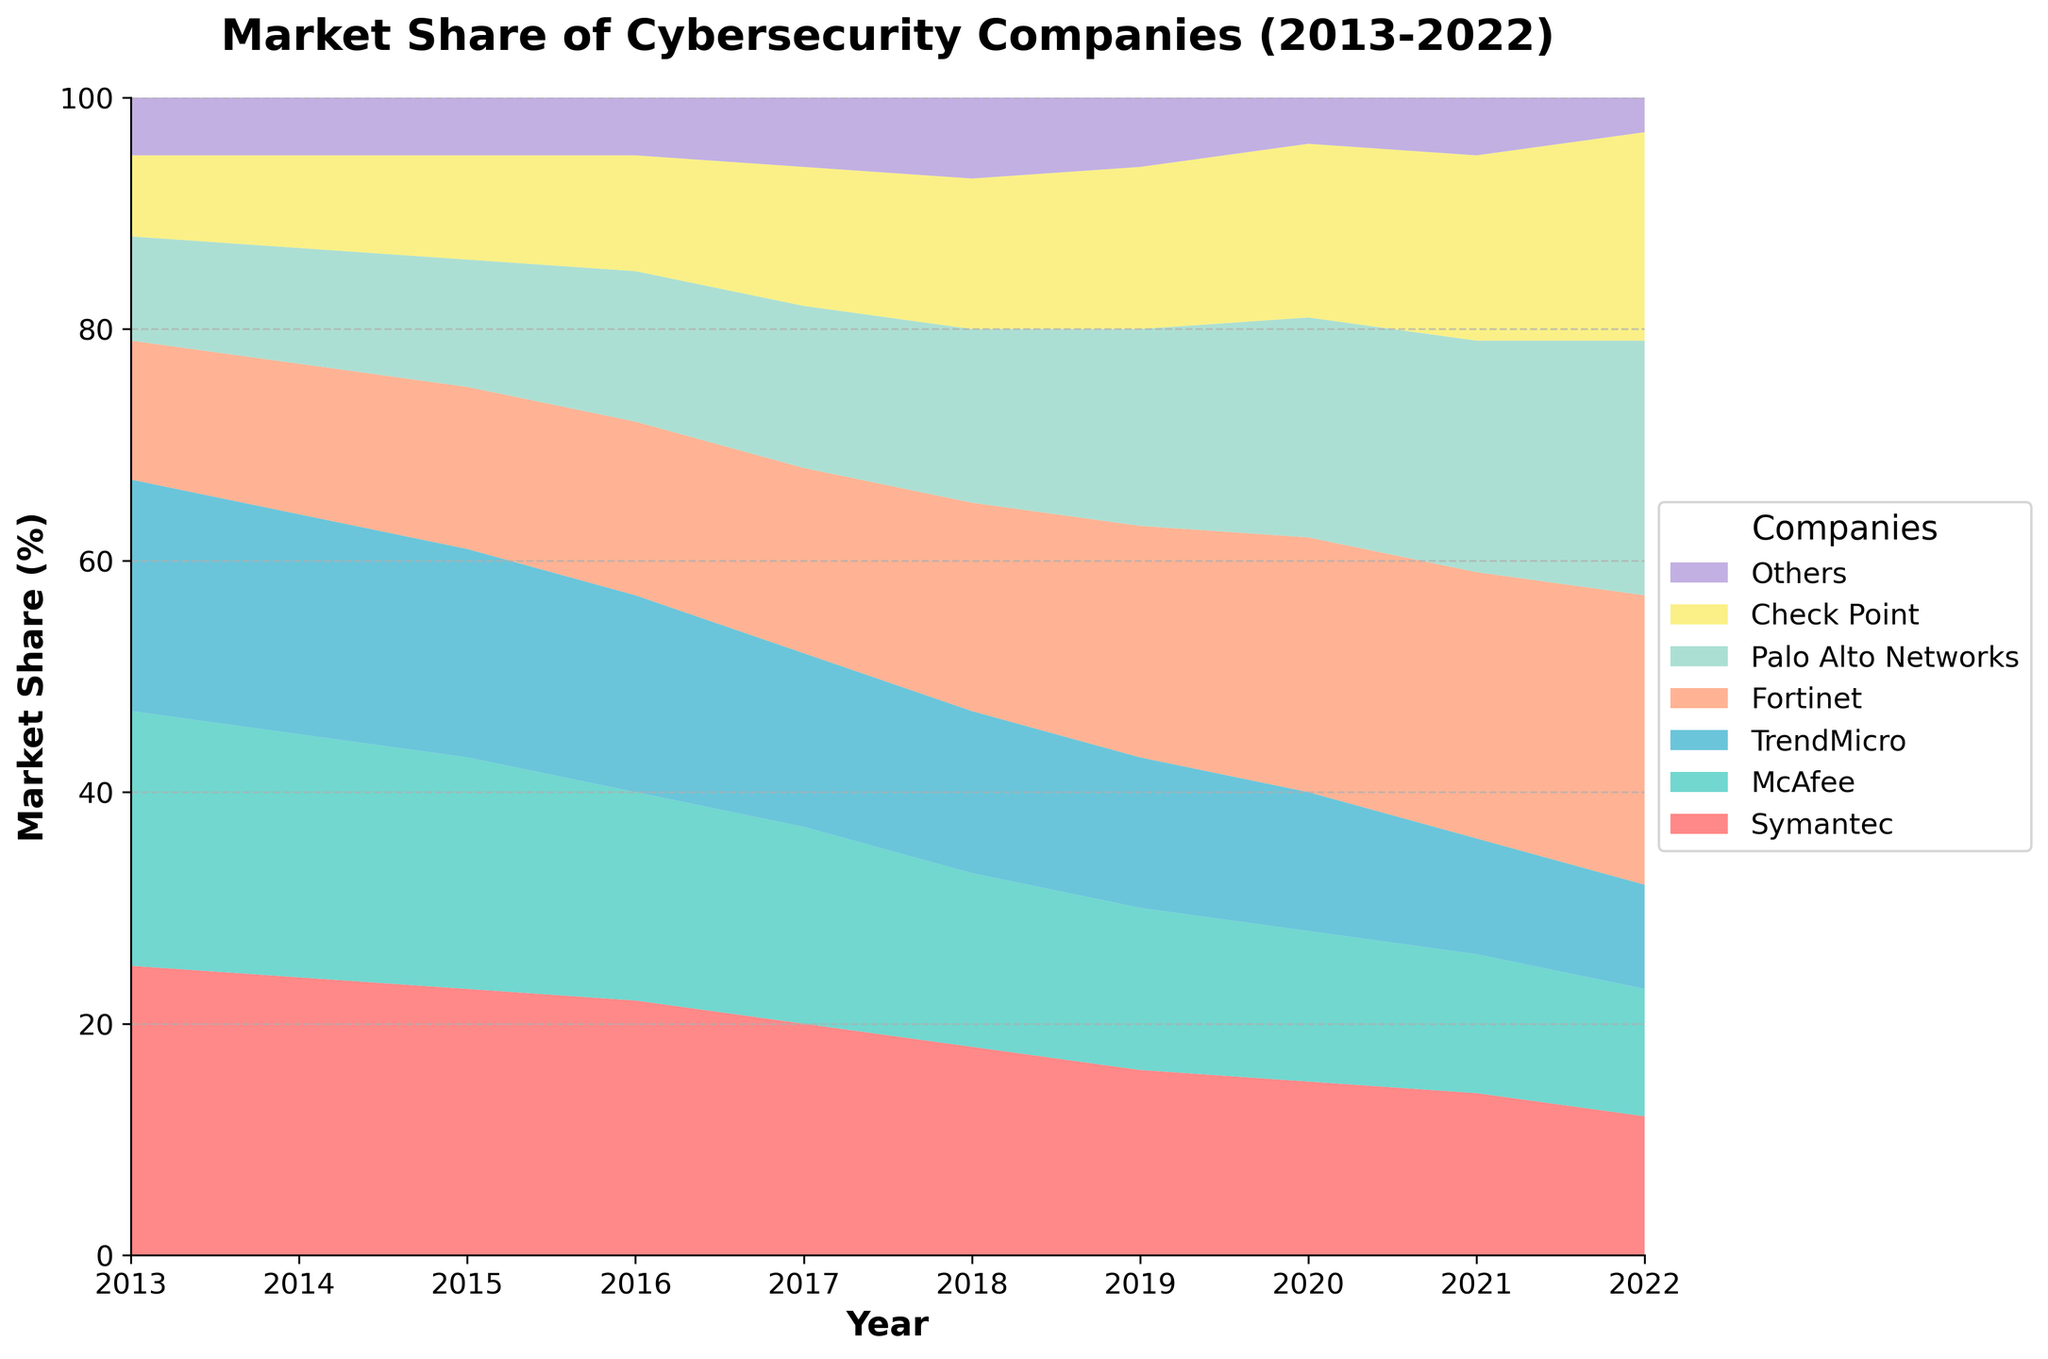What is the title of the chart? The title of the chart is prominently displayed at the top and reads "Market Share of Cybersecurity Companies (2013-2022)."
Answer: Market Share of Cybersecurity Companies (2013-2022) Which company had the highest market share in 2013? According to the chart, Symantec had the highest market share in 2013, indicated by the largest segment at the bottom of the stack for that year.
Answer: Symantec What is the overall trend for Symantec's market share from 2013 to 2022? The trend for Symantec's market share shows a continuous decline from 25% in 2013 to 12% in 2022, as illustrated by the decreasing size of its area in the chart.
Answer: Continuous decline Which company experienced the most growth in market share from 2013 to 2022? Fortinet experienced the most growth in market share, increasing from 12% in 2013 to 25% in 2022, as shown by the expanding area for Fortinet over the years.
Answer: Fortinet How did the combined market share of Palo Alto Networks and Fortinet change from 2013 to 2022? In 2013, Palo Alto Networks had 9% and Fortinet had 12%, combining for 21%. In 2022, Palo Alto Networks had 22% and Fortinet had 25%, combining for 47%. The combined market share increased from 21% to 47%.
Answer: Increased from 21% to 47% Which year did McAfee see its steepest drop in market share, and by how much? McAfee saw its steepest drop in market share from 2016 to 2017, decreasing from 18% to 17%, which is a 1% drop. Even though it's a small margin, it was the most significant annual decrease for McAfee.
Answer: 2017, 1% How did the market share of the 'Others' category change over the decade? The market share for the 'Others' category varied slightly. It started at 5% in 2013, dipped to 4% in 2020, and finally ended at 3% in 2022. This represents an overall decline over the decade.
Answer: Declined Which two companies had an equal market share at any point within the data range? In 2021, McAfee and Check Point both had a market share of 12%, as evidenced by their equally sized areas for that year.
Answer: McAfee and Check Point When did Palo Alto Networks surpass Symantec in market share? Palo Alto Networks surpassed Symantec in market share in 2021, as this is when the area representing Palo Alto Networks became larger than that of Symantec on the chart.
Answer: 2021 What's the approximate difference in market share between Symantec and Palo Alto Networks in 2022? In 2022, Symantec had a market share of 12% and Palo Alto Networks had 22%. The difference between their market shares is 22% - 12% = 10%.
Answer: 10% 